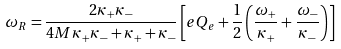Convert formula to latex. <formula><loc_0><loc_0><loc_500><loc_500>\omega _ { R } = \frac { 2 \kappa _ { + } \kappa _ { - } } { 4 M \kappa _ { + } \kappa _ { - } + \kappa _ { + } + \kappa _ { - } } \left [ e Q _ { e } + \frac { 1 } { 2 } \left ( \frac { \omega _ { + } } { \kappa _ { + } } + \frac { \omega _ { - } } { \kappa _ { - } } \right ) \right ]</formula> 